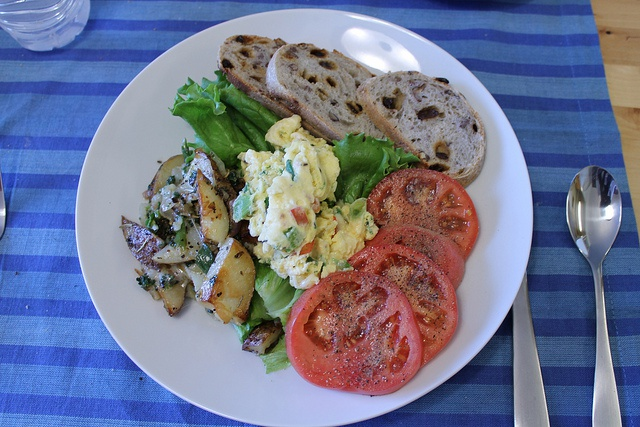Describe the objects in this image and their specific colors. I can see dining table in darkgray, blue, and gray tones, spoon in gray, darkgray, and lightgray tones, cup in gray and darkgray tones, knife in gray tones, and bottle in gray and darkgray tones in this image. 